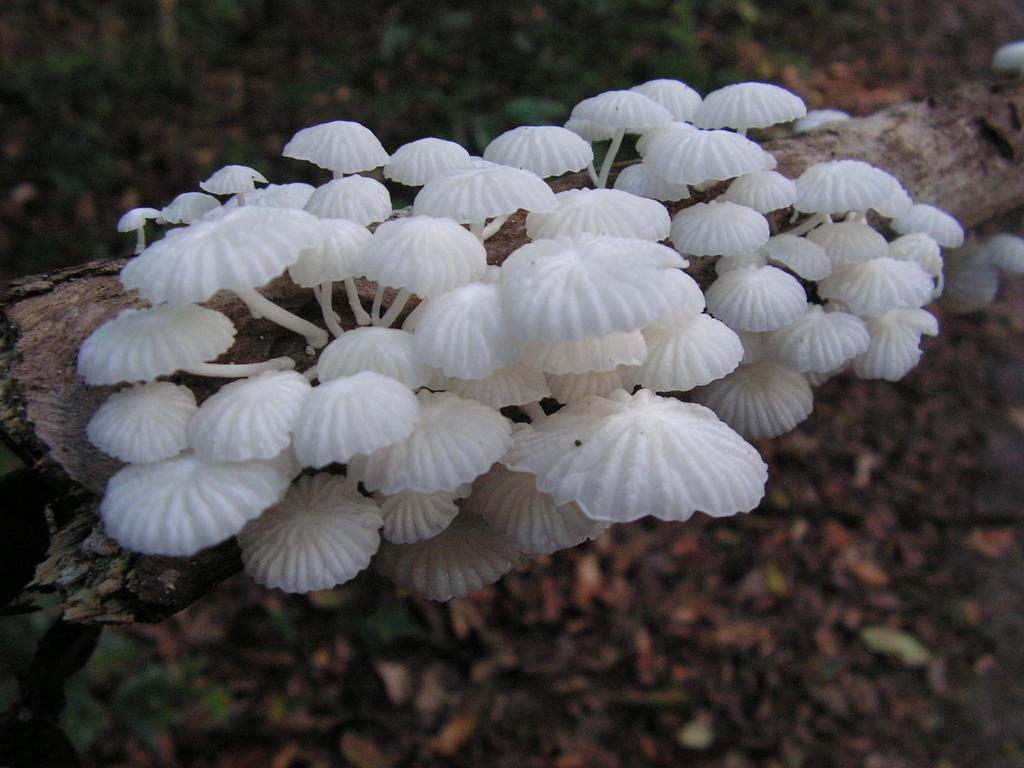What is growing on the tree in the center of the image? There are mushrooms on a tree in the center of the image. What can be seen in the background of the image? There are dry leaves and plants in the background of the image. Where is the giraffe standing in the image? There is no giraffe present in the image. What type of vegetable is growing near the mushrooms on the tree? There is no vegetable, such as cabbage, growing near the mushrooms on the tree in the image. 